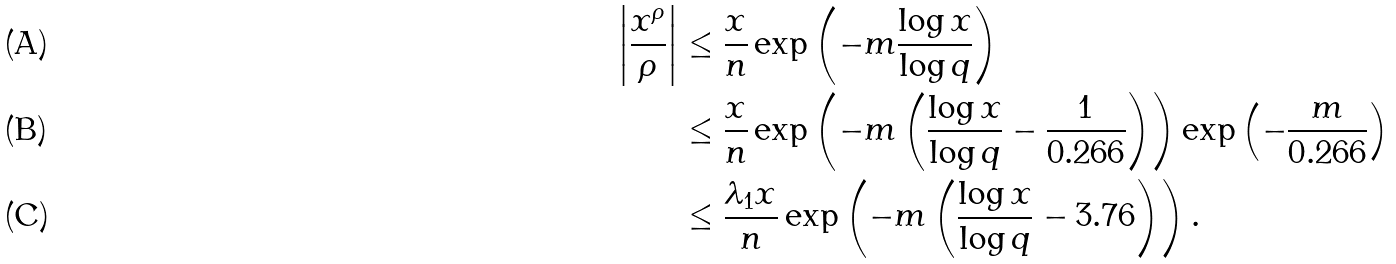Convert formula to latex. <formula><loc_0><loc_0><loc_500><loc_500>\left | \frac { x ^ { \rho } } { \rho } \right | & \leq \frac { x } { n } \exp \left ( - m \frac { \log { x } } { \log { q } } \right ) \\ & \leq \frac { x } { n } \exp \left ( - m \left ( \frac { \log { x } } { \log { q } } - \frac { 1 } { 0 . 2 6 6 } \right ) \right ) \exp \left ( - \frac { m } { 0 . 2 6 6 } \right ) \\ & \leq \frac { \lambda _ { 1 } x } { n } \exp \left ( - m \left ( \frac { \log { x } } { \log { q } } - 3 . 7 6 \right ) \right ) .</formula> 